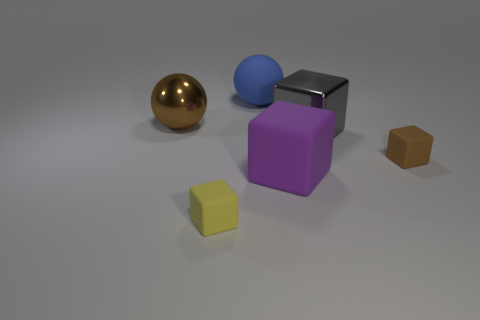What time of day does the lighting in the image suggest? The lighting in the image does not strongly suggest a specific time of day, as it appears to be a controlled, neutral lighting one might find in a studio setup. 